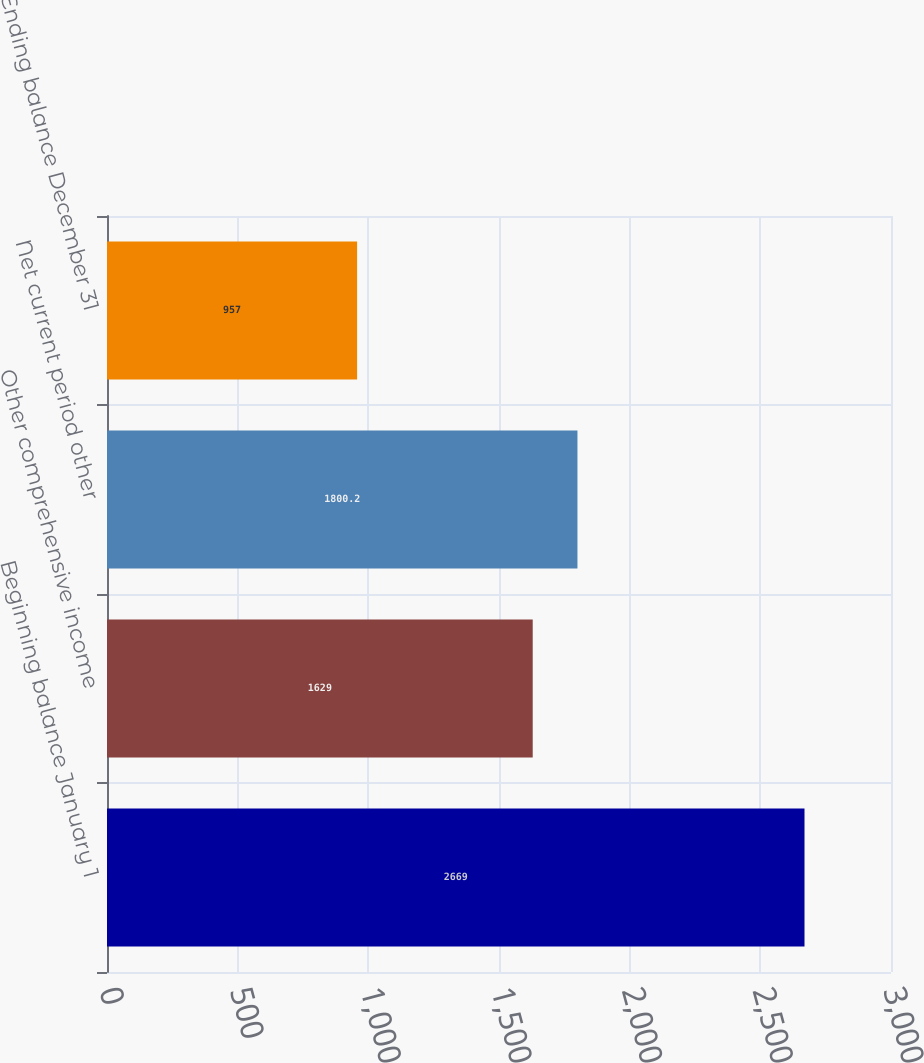<chart> <loc_0><loc_0><loc_500><loc_500><bar_chart><fcel>Beginning balance January 1<fcel>Other comprehensive income<fcel>Net current period other<fcel>Ending balance December 31<nl><fcel>2669<fcel>1629<fcel>1800.2<fcel>957<nl></chart> 